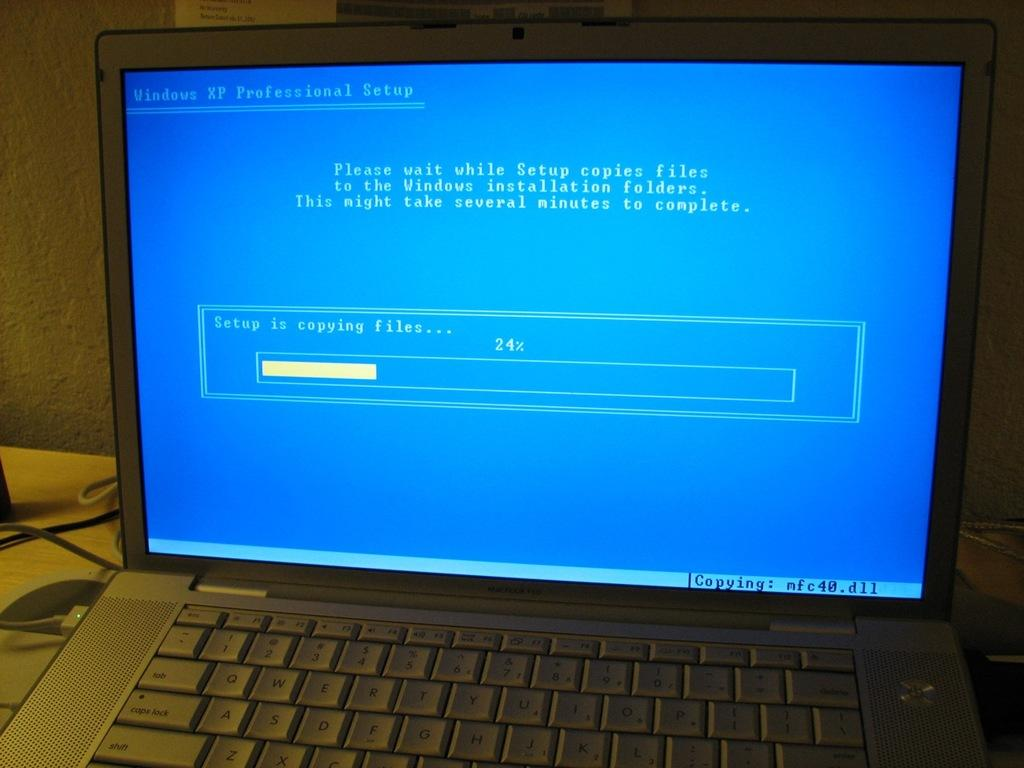<image>
Render a clear and concise summary of the photo. a laptop computer screen that is blue with a progress bar at 24% for setup is copying files 